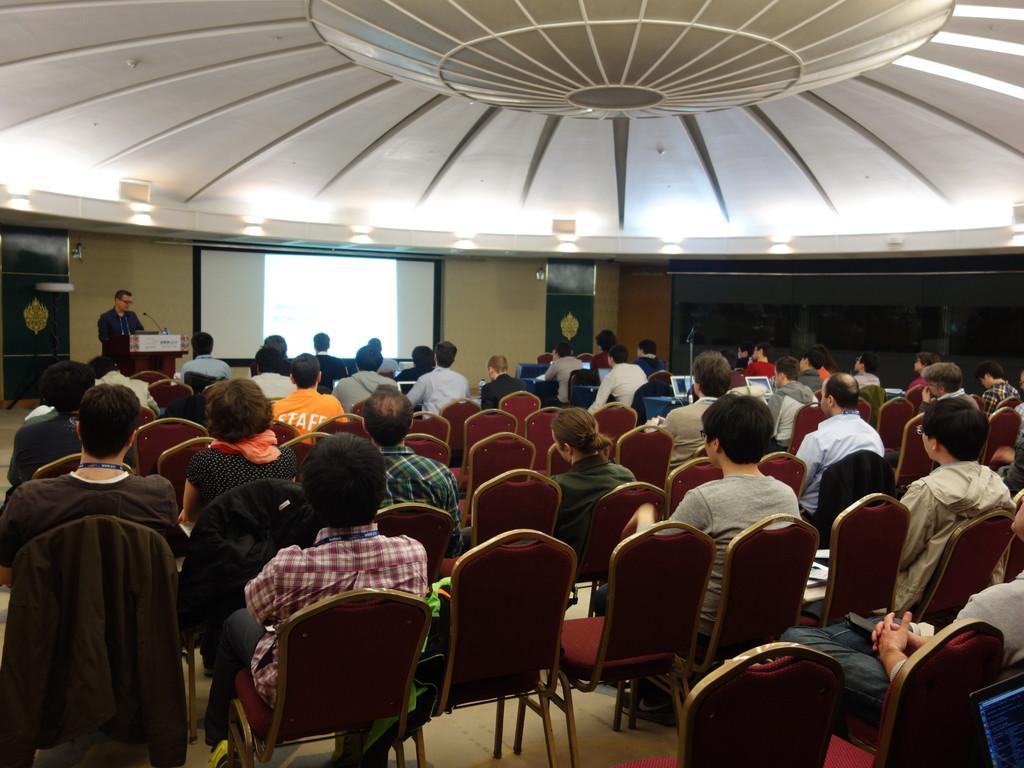How would you summarize this image in a sentence or two? In this image I see lot of people sitting on the chairs and I see a person over here who is in front of the podium and I see a screen. 